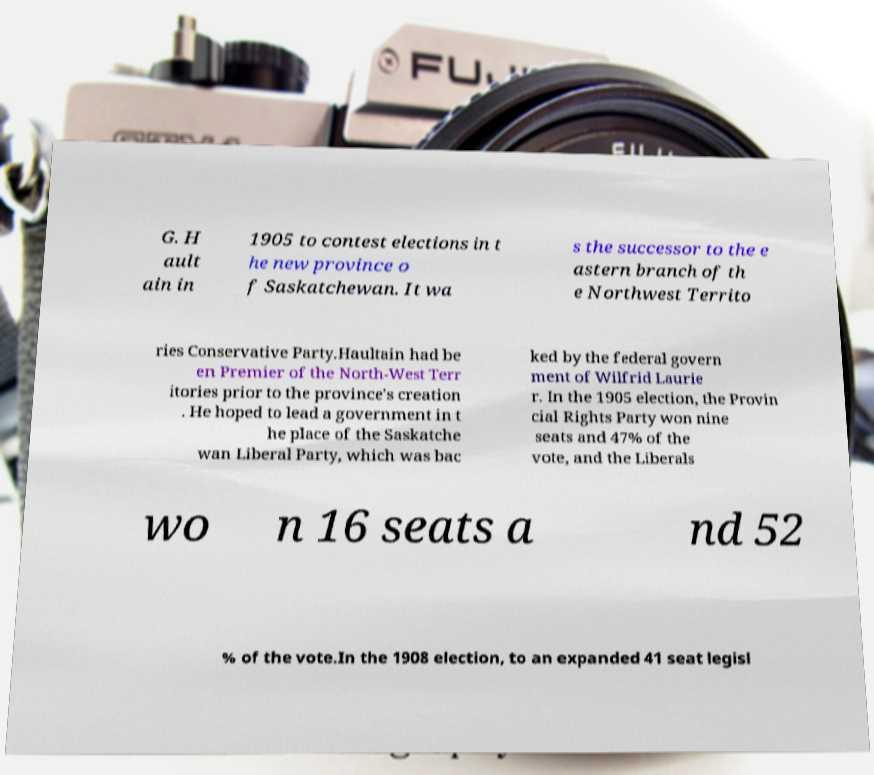Can you accurately transcribe the text from the provided image for me? G. H ault ain in 1905 to contest elections in t he new province o f Saskatchewan. It wa s the successor to the e astern branch of th e Northwest Territo ries Conservative Party.Haultain had be en Premier of the North-West Terr itories prior to the province's creation . He hoped to lead a government in t he place of the Saskatche wan Liberal Party, which was bac ked by the federal govern ment of Wilfrid Laurie r. In the 1905 election, the Provin cial Rights Party won nine seats and 47% of the vote, and the Liberals wo n 16 seats a nd 52 % of the vote.In the 1908 election, to an expanded 41 seat legisl 